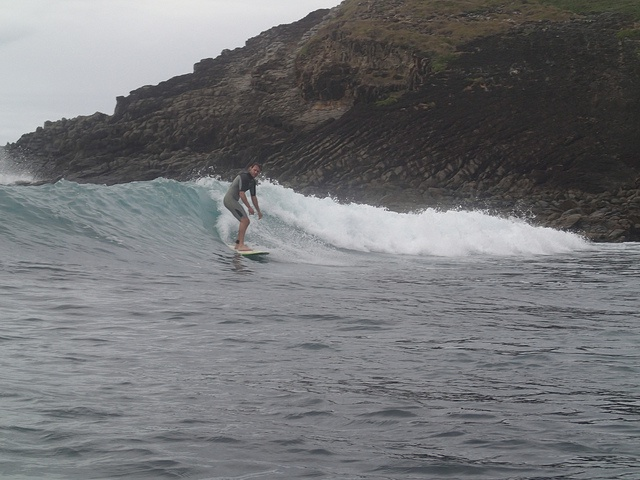Describe the objects in this image and their specific colors. I can see people in lightgray, gray, darkgray, and black tones and surfboard in lightgray, darkgray, gray, and black tones in this image. 